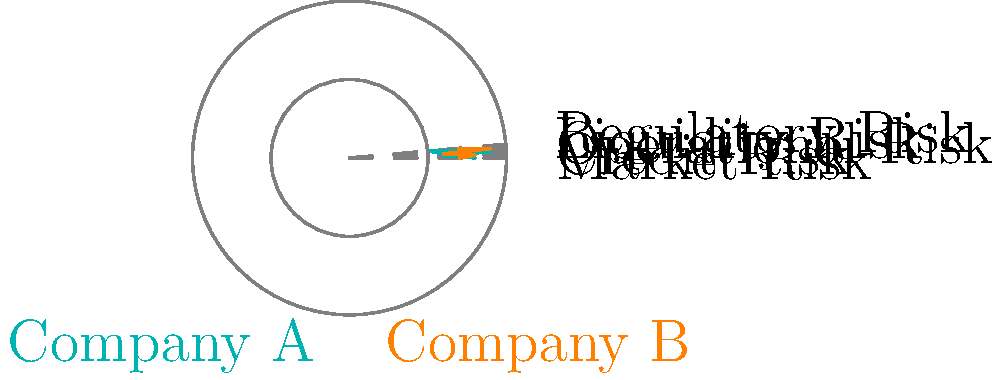As an influential investor, you're comparing the risk profiles of two companies using the radar chart above. Which company presents a higher overall risk based on the areas covered by their respective risk profiles, and what immediate action would you recommend to the management of the riskier company? To determine which company presents a higher overall risk, we need to analyze the areas covered by each company's risk profile in the radar chart. A larger area indicates a higher overall risk.

Step 1: Analyze Company A's risk profile (teal)
- High operational risk (0.9)
- Moderate market risk (0.8) and liquidity risk (0.7)
- Lower credit risk (0.6) and regulatory risk (0.5)

Step 2: Analyze Company B's risk profile (orange)
- High liquidity risk (0.9)
- Relatively high credit risk (0.8) and regulatory risk (0.7)
- Moderate market risk (0.7) and operational risk (0.6)

Step 3: Compare the overall areas
Company B's risk profile covers a larger area than Company A's, indicating a higher overall risk.

Step 4: Identify the most critical risk factor for Company B
Liquidity risk is the highest (0.9) for Company B, which could lead to immediate financial difficulties.

Step 5: Recommend immediate action
As an influential investor demanding swift resolution, the immediate recommendation would be for Company B's management to focus on improving their liquidity position. This could involve:
1. Reviewing and optimizing cash flow management
2. Exploring additional funding sources
3. Potentially divesting non-core assets to increase cash reserves

This action addresses the most pressing risk while demonstrating a commitment to transparency and risk mitigation to investors.
Answer: Company B; Improve liquidity position immediately 